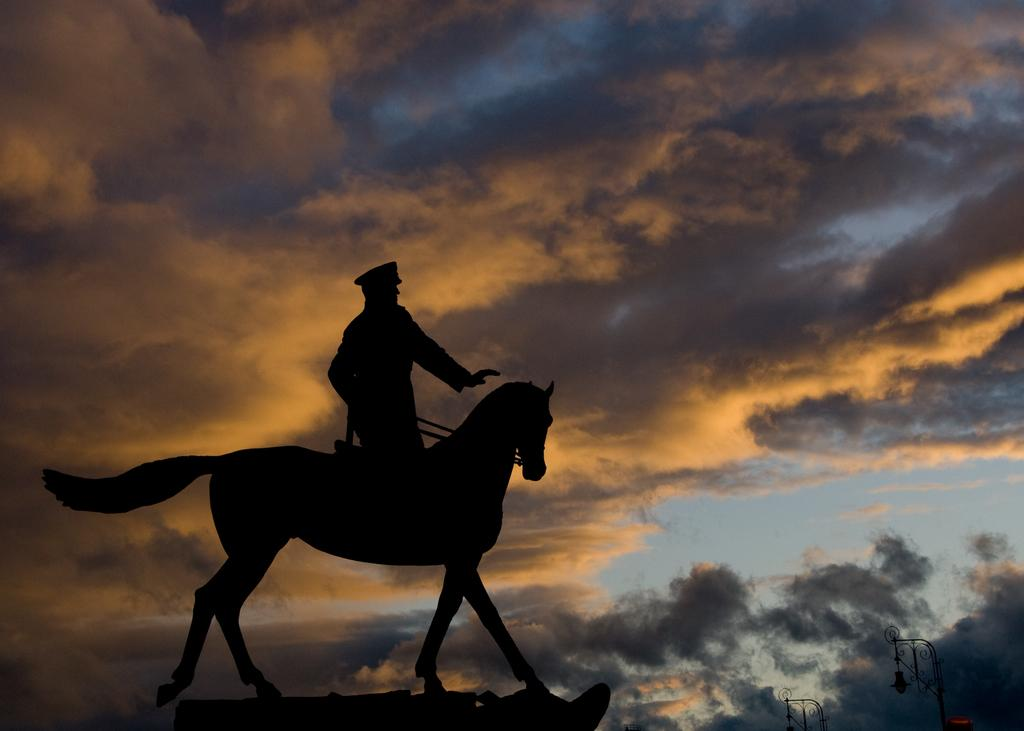What is the main subject of the image? There is a person sitting on a horse in the image. What can be seen in the background of the image? There are light poles visible in the background. How would you describe the sky in the image? The sky is a combination of blue, orange, and black colors. What type of ornament is the person offering to the horse in the image? There is no ornament present in the image, and the person is not offering anything to the horse. 